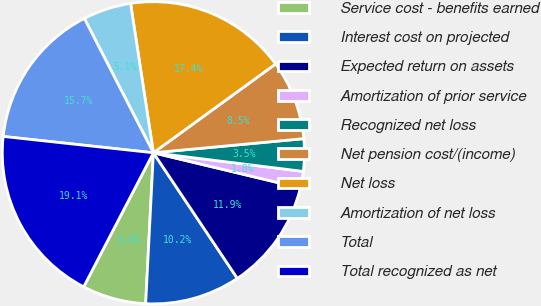Convert chart. <chart><loc_0><loc_0><loc_500><loc_500><pie_chart><fcel>Service cost - benefits earned<fcel>Interest cost on projected<fcel>Expected return on assets<fcel>Amortization of prior service<fcel>Recognized net loss<fcel>Net pension cost/(income)<fcel>Net loss<fcel>Amortization of net loss<fcel>Total<fcel>Total recognized as net<nl><fcel>6.82%<fcel>10.19%<fcel>11.88%<fcel>1.77%<fcel>3.46%<fcel>8.51%<fcel>17.41%<fcel>5.14%<fcel>15.72%<fcel>19.09%<nl></chart> 